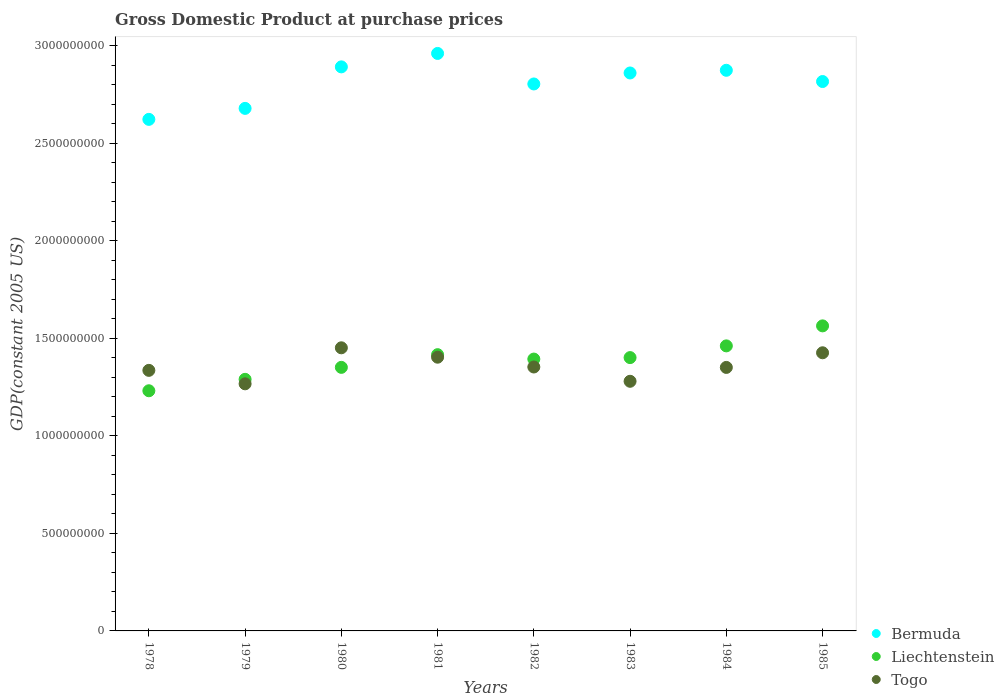How many different coloured dotlines are there?
Give a very brief answer. 3. Is the number of dotlines equal to the number of legend labels?
Offer a terse response. Yes. What is the GDP at purchase prices in Bermuda in 1981?
Provide a succinct answer. 2.96e+09. Across all years, what is the maximum GDP at purchase prices in Bermuda?
Ensure brevity in your answer.  2.96e+09. Across all years, what is the minimum GDP at purchase prices in Liechtenstein?
Give a very brief answer. 1.23e+09. In which year was the GDP at purchase prices in Togo maximum?
Your answer should be compact. 1980. In which year was the GDP at purchase prices in Togo minimum?
Make the answer very short. 1979. What is the total GDP at purchase prices in Liechtenstein in the graph?
Make the answer very short. 1.11e+1. What is the difference between the GDP at purchase prices in Liechtenstein in 1983 and that in 1984?
Provide a succinct answer. -6.01e+07. What is the difference between the GDP at purchase prices in Liechtenstein in 1984 and the GDP at purchase prices in Bermuda in 1982?
Your answer should be very brief. -1.34e+09. What is the average GDP at purchase prices in Bermuda per year?
Offer a terse response. 2.81e+09. In the year 1983, what is the difference between the GDP at purchase prices in Togo and GDP at purchase prices in Bermuda?
Your answer should be compact. -1.58e+09. In how many years, is the GDP at purchase prices in Togo greater than 800000000 US$?
Your answer should be compact. 8. What is the ratio of the GDP at purchase prices in Togo in 1981 to that in 1982?
Your response must be concise. 1.04. What is the difference between the highest and the second highest GDP at purchase prices in Togo?
Offer a very short reply. 2.55e+07. What is the difference between the highest and the lowest GDP at purchase prices in Bermuda?
Your answer should be compact. 3.38e+08. Is the sum of the GDP at purchase prices in Togo in 1979 and 1984 greater than the maximum GDP at purchase prices in Liechtenstein across all years?
Provide a short and direct response. Yes. Is it the case that in every year, the sum of the GDP at purchase prices in Togo and GDP at purchase prices in Liechtenstein  is greater than the GDP at purchase prices in Bermuda?
Your answer should be very brief. No. Is the GDP at purchase prices in Togo strictly greater than the GDP at purchase prices in Bermuda over the years?
Offer a terse response. No. Is the GDP at purchase prices in Liechtenstein strictly less than the GDP at purchase prices in Bermuda over the years?
Your answer should be compact. Yes. How many years are there in the graph?
Offer a terse response. 8. Are the values on the major ticks of Y-axis written in scientific E-notation?
Your answer should be compact. No. Does the graph contain grids?
Your answer should be compact. No. How many legend labels are there?
Make the answer very short. 3. What is the title of the graph?
Your response must be concise. Gross Domestic Product at purchase prices. Does "West Bank and Gaza" appear as one of the legend labels in the graph?
Provide a short and direct response. No. What is the label or title of the Y-axis?
Make the answer very short. GDP(constant 2005 US). What is the GDP(constant 2005 US) in Bermuda in 1978?
Make the answer very short. 2.62e+09. What is the GDP(constant 2005 US) of Liechtenstein in 1978?
Keep it short and to the point. 1.23e+09. What is the GDP(constant 2005 US) of Togo in 1978?
Ensure brevity in your answer.  1.34e+09. What is the GDP(constant 2005 US) in Bermuda in 1979?
Keep it short and to the point. 2.68e+09. What is the GDP(constant 2005 US) in Liechtenstein in 1979?
Offer a very short reply. 1.29e+09. What is the GDP(constant 2005 US) in Togo in 1979?
Your answer should be very brief. 1.27e+09. What is the GDP(constant 2005 US) in Bermuda in 1980?
Offer a very short reply. 2.89e+09. What is the GDP(constant 2005 US) of Liechtenstein in 1980?
Your response must be concise. 1.35e+09. What is the GDP(constant 2005 US) of Togo in 1980?
Give a very brief answer. 1.45e+09. What is the GDP(constant 2005 US) in Bermuda in 1981?
Provide a short and direct response. 2.96e+09. What is the GDP(constant 2005 US) in Liechtenstein in 1981?
Make the answer very short. 1.42e+09. What is the GDP(constant 2005 US) of Togo in 1981?
Your response must be concise. 1.40e+09. What is the GDP(constant 2005 US) of Bermuda in 1982?
Offer a terse response. 2.80e+09. What is the GDP(constant 2005 US) of Liechtenstein in 1982?
Give a very brief answer. 1.39e+09. What is the GDP(constant 2005 US) of Togo in 1982?
Your answer should be compact. 1.35e+09. What is the GDP(constant 2005 US) in Bermuda in 1983?
Provide a succinct answer. 2.86e+09. What is the GDP(constant 2005 US) of Liechtenstein in 1983?
Offer a very short reply. 1.40e+09. What is the GDP(constant 2005 US) in Togo in 1983?
Make the answer very short. 1.28e+09. What is the GDP(constant 2005 US) in Bermuda in 1984?
Provide a succinct answer. 2.87e+09. What is the GDP(constant 2005 US) in Liechtenstein in 1984?
Keep it short and to the point. 1.46e+09. What is the GDP(constant 2005 US) in Togo in 1984?
Your answer should be compact. 1.35e+09. What is the GDP(constant 2005 US) in Bermuda in 1985?
Give a very brief answer. 2.82e+09. What is the GDP(constant 2005 US) of Liechtenstein in 1985?
Keep it short and to the point. 1.56e+09. What is the GDP(constant 2005 US) of Togo in 1985?
Your answer should be very brief. 1.43e+09. Across all years, what is the maximum GDP(constant 2005 US) in Bermuda?
Make the answer very short. 2.96e+09. Across all years, what is the maximum GDP(constant 2005 US) in Liechtenstein?
Provide a short and direct response. 1.56e+09. Across all years, what is the maximum GDP(constant 2005 US) of Togo?
Give a very brief answer. 1.45e+09. Across all years, what is the minimum GDP(constant 2005 US) of Bermuda?
Ensure brevity in your answer.  2.62e+09. Across all years, what is the minimum GDP(constant 2005 US) in Liechtenstein?
Give a very brief answer. 1.23e+09. Across all years, what is the minimum GDP(constant 2005 US) in Togo?
Ensure brevity in your answer.  1.27e+09. What is the total GDP(constant 2005 US) in Bermuda in the graph?
Give a very brief answer. 2.25e+1. What is the total GDP(constant 2005 US) in Liechtenstein in the graph?
Keep it short and to the point. 1.11e+1. What is the total GDP(constant 2005 US) of Togo in the graph?
Your answer should be very brief. 1.09e+1. What is the difference between the GDP(constant 2005 US) in Bermuda in 1978 and that in 1979?
Make the answer very short. -5.63e+07. What is the difference between the GDP(constant 2005 US) in Liechtenstein in 1978 and that in 1979?
Offer a very short reply. -5.86e+07. What is the difference between the GDP(constant 2005 US) of Togo in 1978 and that in 1979?
Provide a short and direct response. 6.90e+07. What is the difference between the GDP(constant 2005 US) of Bermuda in 1978 and that in 1980?
Offer a terse response. -2.69e+08. What is the difference between the GDP(constant 2005 US) of Liechtenstein in 1978 and that in 1980?
Offer a very short reply. -1.20e+08. What is the difference between the GDP(constant 2005 US) in Togo in 1978 and that in 1980?
Provide a short and direct response. -1.16e+08. What is the difference between the GDP(constant 2005 US) in Bermuda in 1978 and that in 1981?
Keep it short and to the point. -3.38e+08. What is the difference between the GDP(constant 2005 US) in Liechtenstein in 1978 and that in 1981?
Offer a very short reply. -1.85e+08. What is the difference between the GDP(constant 2005 US) of Togo in 1978 and that in 1981?
Make the answer very short. -6.75e+07. What is the difference between the GDP(constant 2005 US) in Bermuda in 1978 and that in 1982?
Offer a very short reply. -1.82e+08. What is the difference between the GDP(constant 2005 US) of Liechtenstein in 1978 and that in 1982?
Make the answer very short. -1.63e+08. What is the difference between the GDP(constant 2005 US) in Togo in 1978 and that in 1982?
Offer a very short reply. -1.72e+07. What is the difference between the GDP(constant 2005 US) in Bermuda in 1978 and that in 1983?
Offer a very short reply. -2.38e+08. What is the difference between the GDP(constant 2005 US) of Liechtenstein in 1978 and that in 1983?
Make the answer very short. -1.70e+08. What is the difference between the GDP(constant 2005 US) in Togo in 1978 and that in 1983?
Your answer should be very brief. 5.60e+07. What is the difference between the GDP(constant 2005 US) of Bermuda in 1978 and that in 1984?
Offer a very short reply. -2.52e+08. What is the difference between the GDP(constant 2005 US) in Liechtenstein in 1978 and that in 1984?
Your response must be concise. -2.30e+08. What is the difference between the GDP(constant 2005 US) of Togo in 1978 and that in 1984?
Offer a very short reply. -1.51e+07. What is the difference between the GDP(constant 2005 US) of Bermuda in 1978 and that in 1985?
Keep it short and to the point. -1.94e+08. What is the difference between the GDP(constant 2005 US) of Liechtenstein in 1978 and that in 1985?
Your answer should be very brief. -3.33e+08. What is the difference between the GDP(constant 2005 US) of Togo in 1978 and that in 1985?
Offer a very short reply. -9.01e+07. What is the difference between the GDP(constant 2005 US) in Bermuda in 1979 and that in 1980?
Provide a short and direct response. -2.13e+08. What is the difference between the GDP(constant 2005 US) of Liechtenstein in 1979 and that in 1980?
Make the answer very short. -6.14e+07. What is the difference between the GDP(constant 2005 US) of Togo in 1979 and that in 1980?
Make the answer very short. -1.85e+08. What is the difference between the GDP(constant 2005 US) in Bermuda in 1979 and that in 1981?
Provide a succinct answer. -2.82e+08. What is the difference between the GDP(constant 2005 US) of Liechtenstein in 1979 and that in 1981?
Offer a terse response. -1.26e+08. What is the difference between the GDP(constant 2005 US) of Togo in 1979 and that in 1981?
Your answer should be very brief. -1.37e+08. What is the difference between the GDP(constant 2005 US) in Bermuda in 1979 and that in 1982?
Provide a succinct answer. -1.25e+08. What is the difference between the GDP(constant 2005 US) in Liechtenstein in 1979 and that in 1982?
Your response must be concise. -1.04e+08. What is the difference between the GDP(constant 2005 US) in Togo in 1979 and that in 1982?
Offer a very short reply. -8.63e+07. What is the difference between the GDP(constant 2005 US) in Bermuda in 1979 and that in 1983?
Your response must be concise. -1.82e+08. What is the difference between the GDP(constant 2005 US) of Liechtenstein in 1979 and that in 1983?
Your answer should be compact. -1.11e+08. What is the difference between the GDP(constant 2005 US) of Togo in 1979 and that in 1983?
Make the answer very short. -1.30e+07. What is the difference between the GDP(constant 2005 US) in Bermuda in 1979 and that in 1984?
Your answer should be compact. -1.95e+08. What is the difference between the GDP(constant 2005 US) of Liechtenstein in 1979 and that in 1984?
Your answer should be compact. -1.72e+08. What is the difference between the GDP(constant 2005 US) of Togo in 1979 and that in 1984?
Give a very brief answer. -8.41e+07. What is the difference between the GDP(constant 2005 US) of Bermuda in 1979 and that in 1985?
Your answer should be very brief. -1.38e+08. What is the difference between the GDP(constant 2005 US) of Liechtenstein in 1979 and that in 1985?
Your response must be concise. -2.74e+08. What is the difference between the GDP(constant 2005 US) in Togo in 1979 and that in 1985?
Provide a succinct answer. -1.59e+08. What is the difference between the GDP(constant 2005 US) in Bermuda in 1980 and that in 1981?
Offer a very short reply. -6.89e+07. What is the difference between the GDP(constant 2005 US) in Liechtenstein in 1980 and that in 1981?
Your answer should be compact. -6.51e+07. What is the difference between the GDP(constant 2005 US) of Togo in 1980 and that in 1981?
Give a very brief answer. 4.81e+07. What is the difference between the GDP(constant 2005 US) of Bermuda in 1980 and that in 1982?
Ensure brevity in your answer.  8.76e+07. What is the difference between the GDP(constant 2005 US) in Liechtenstein in 1980 and that in 1982?
Offer a terse response. -4.25e+07. What is the difference between the GDP(constant 2005 US) in Togo in 1980 and that in 1982?
Give a very brief answer. 9.84e+07. What is the difference between the GDP(constant 2005 US) of Bermuda in 1980 and that in 1983?
Provide a succinct answer. 3.13e+07. What is the difference between the GDP(constant 2005 US) in Liechtenstein in 1980 and that in 1983?
Offer a terse response. -5.01e+07. What is the difference between the GDP(constant 2005 US) of Togo in 1980 and that in 1983?
Give a very brief answer. 1.72e+08. What is the difference between the GDP(constant 2005 US) of Bermuda in 1980 and that in 1984?
Make the answer very short. 1.75e+07. What is the difference between the GDP(constant 2005 US) of Liechtenstein in 1980 and that in 1984?
Keep it short and to the point. -1.10e+08. What is the difference between the GDP(constant 2005 US) of Togo in 1980 and that in 1984?
Offer a very short reply. 1.01e+08. What is the difference between the GDP(constant 2005 US) in Bermuda in 1980 and that in 1985?
Your response must be concise. 7.51e+07. What is the difference between the GDP(constant 2005 US) in Liechtenstein in 1980 and that in 1985?
Your answer should be compact. -2.13e+08. What is the difference between the GDP(constant 2005 US) in Togo in 1980 and that in 1985?
Your response must be concise. 2.55e+07. What is the difference between the GDP(constant 2005 US) of Bermuda in 1981 and that in 1982?
Make the answer very short. 1.57e+08. What is the difference between the GDP(constant 2005 US) of Liechtenstein in 1981 and that in 1982?
Your answer should be very brief. 2.25e+07. What is the difference between the GDP(constant 2005 US) in Togo in 1981 and that in 1982?
Give a very brief answer. 5.03e+07. What is the difference between the GDP(constant 2005 US) in Bermuda in 1981 and that in 1983?
Your answer should be very brief. 1.00e+08. What is the difference between the GDP(constant 2005 US) in Liechtenstein in 1981 and that in 1983?
Your answer should be very brief. 1.50e+07. What is the difference between the GDP(constant 2005 US) of Togo in 1981 and that in 1983?
Ensure brevity in your answer.  1.24e+08. What is the difference between the GDP(constant 2005 US) of Bermuda in 1981 and that in 1984?
Make the answer very short. 8.64e+07. What is the difference between the GDP(constant 2005 US) in Liechtenstein in 1981 and that in 1984?
Keep it short and to the point. -4.50e+07. What is the difference between the GDP(constant 2005 US) of Togo in 1981 and that in 1984?
Offer a very short reply. 5.24e+07. What is the difference between the GDP(constant 2005 US) in Bermuda in 1981 and that in 1985?
Offer a terse response. 1.44e+08. What is the difference between the GDP(constant 2005 US) of Liechtenstein in 1981 and that in 1985?
Make the answer very short. -1.48e+08. What is the difference between the GDP(constant 2005 US) in Togo in 1981 and that in 1985?
Provide a succinct answer. -2.26e+07. What is the difference between the GDP(constant 2005 US) of Bermuda in 1982 and that in 1983?
Provide a short and direct response. -5.63e+07. What is the difference between the GDP(constant 2005 US) in Liechtenstein in 1982 and that in 1983?
Give a very brief answer. -7.51e+06. What is the difference between the GDP(constant 2005 US) of Togo in 1982 and that in 1983?
Your response must be concise. 7.33e+07. What is the difference between the GDP(constant 2005 US) in Bermuda in 1982 and that in 1984?
Provide a succinct answer. -7.01e+07. What is the difference between the GDP(constant 2005 US) in Liechtenstein in 1982 and that in 1984?
Provide a succinct answer. -6.76e+07. What is the difference between the GDP(constant 2005 US) of Togo in 1982 and that in 1984?
Ensure brevity in your answer.  2.15e+06. What is the difference between the GDP(constant 2005 US) in Bermuda in 1982 and that in 1985?
Your response must be concise. -1.25e+07. What is the difference between the GDP(constant 2005 US) in Liechtenstein in 1982 and that in 1985?
Provide a succinct answer. -1.70e+08. What is the difference between the GDP(constant 2005 US) in Togo in 1982 and that in 1985?
Your answer should be very brief. -7.29e+07. What is the difference between the GDP(constant 2005 US) of Bermuda in 1983 and that in 1984?
Offer a terse response. -1.38e+07. What is the difference between the GDP(constant 2005 US) of Liechtenstein in 1983 and that in 1984?
Offer a terse response. -6.01e+07. What is the difference between the GDP(constant 2005 US) in Togo in 1983 and that in 1984?
Offer a terse response. -7.11e+07. What is the difference between the GDP(constant 2005 US) of Bermuda in 1983 and that in 1985?
Provide a short and direct response. 4.38e+07. What is the difference between the GDP(constant 2005 US) of Liechtenstein in 1983 and that in 1985?
Offer a terse response. -1.63e+08. What is the difference between the GDP(constant 2005 US) in Togo in 1983 and that in 1985?
Offer a very short reply. -1.46e+08. What is the difference between the GDP(constant 2005 US) of Bermuda in 1984 and that in 1985?
Your response must be concise. 5.76e+07. What is the difference between the GDP(constant 2005 US) in Liechtenstein in 1984 and that in 1985?
Provide a short and direct response. -1.03e+08. What is the difference between the GDP(constant 2005 US) of Togo in 1984 and that in 1985?
Offer a very short reply. -7.51e+07. What is the difference between the GDP(constant 2005 US) of Bermuda in 1978 and the GDP(constant 2005 US) of Liechtenstein in 1979?
Keep it short and to the point. 1.33e+09. What is the difference between the GDP(constant 2005 US) of Bermuda in 1978 and the GDP(constant 2005 US) of Togo in 1979?
Provide a succinct answer. 1.36e+09. What is the difference between the GDP(constant 2005 US) in Liechtenstein in 1978 and the GDP(constant 2005 US) in Togo in 1979?
Make the answer very short. -3.56e+07. What is the difference between the GDP(constant 2005 US) of Bermuda in 1978 and the GDP(constant 2005 US) of Liechtenstein in 1980?
Your response must be concise. 1.27e+09. What is the difference between the GDP(constant 2005 US) in Bermuda in 1978 and the GDP(constant 2005 US) in Togo in 1980?
Provide a succinct answer. 1.17e+09. What is the difference between the GDP(constant 2005 US) in Liechtenstein in 1978 and the GDP(constant 2005 US) in Togo in 1980?
Provide a succinct answer. -2.20e+08. What is the difference between the GDP(constant 2005 US) in Bermuda in 1978 and the GDP(constant 2005 US) in Liechtenstein in 1981?
Provide a short and direct response. 1.21e+09. What is the difference between the GDP(constant 2005 US) of Bermuda in 1978 and the GDP(constant 2005 US) of Togo in 1981?
Your answer should be very brief. 1.22e+09. What is the difference between the GDP(constant 2005 US) in Liechtenstein in 1978 and the GDP(constant 2005 US) in Togo in 1981?
Provide a short and direct response. -1.72e+08. What is the difference between the GDP(constant 2005 US) of Bermuda in 1978 and the GDP(constant 2005 US) of Liechtenstein in 1982?
Offer a very short reply. 1.23e+09. What is the difference between the GDP(constant 2005 US) of Bermuda in 1978 and the GDP(constant 2005 US) of Togo in 1982?
Your answer should be compact. 1.27e+09. What is the difference between the GDP(constant 2005 US) of Liechtenstein in 1978 and the GDP(constant 2005 US) of Togo in 1982?
Provide a succinct answer. -1.22e+08. What is the difference between the GDP(constant 2005 US) in Bermuda in 1978 and the GDP(constant 2005 US) in Liechtenstein in 1983?
Provide a short and direct response. 1.22e+09. What is the difference between the GDP(constant 2005 US) in Bermuda in 1978 and the GDP(constant 2005 US) in Togo in 1983?
Offer a very short reply. 1.34e+09. What is the difference between the GDP(constant 2005 US) in Liechtenstein in 1978 and the GDP(constant 2005 US) in Togo in 1983?
Make the answer very short. -4.86e+07. What is the difference between the GDP(constant 2005 US) of Bermuda in 1978 and the GDP(constant 2005 US) of Liechtenstein in 1984?
Provide a succinct answer. 1.16e+09. What is the difference between the GDP(constant 2005 US) in Bermuda in 1978 and the GDP(constant 2005 US) in Togo in 1984?
Offer a very short reply. 1.27e+09. What is the difference between the GDP(constant 2005 US) of Liechtenstein in 1978 and the GDP(constant 2005 US) of Togo in 1984?
Offer a very short reply. -1.20e+08. What is the difference between the GDP(constant 2005 US) of Bermuda in 1978 and the GDP(constant 2005 US) of Liechtenstein in 1985?
Your answer should be very brief. 1.06e+09. What is the difference between the GDP(constant 2005 US) of Bermuda in 1978 and the GDP(constant 2005 US) of Togo in 1985?
Keep it short and to the point. 1.20e+09. What is the difference between the GDP(constant 2005 US) in Liechtenstein in 1978 and the GDP(constant 2005 US) in Togo in 1985?
Offer a terse response. -1.95e+08. What is the difference between the GDP(constant 2005 US) of Bermuda in 1979 and the GDP(constant 2005 US) of Liechtenstein in 1980?
Provide a short and direct response. 1.33e+09. What is the difference between the GDP(constant 2005 US) of Bermuda in 1979 and the GDP(constant 2005 US) of Togo in 1980?
Offer a terse response. 1.23e+09. What is the difference between the GDP(constant 2005 US) of Liechtenstein in 1979 and the GDP(constant 2005 US) of Togo in 1980?
Your response must be concise. -1.62e+08. What is the difference between the GDP(constant 2005 US) in Bermuda in 1979 and the GDP(constant 2005 US) in Liechtenstein in 1981?
Give a very brief answer. 1.26e+09. What is the difference between the GDP(constant 2005 US) in Bermuda in 1979 and the GDP(constant 2005 US) in Togo in 1981?
Provide a short and direct response. 1.28e+09. What is the difference between the GDP(constant 2005 US) of Liechtenstein in 1979 and the GDP(constant 2005 US) of Togo in 1981?
Ensure brevity in your answer.  -1.14e+08. What is the difference between the GDP(constant 2005 US) of Bermuda in 1979 and the GDP(constant 2005 US) of Liechtenstein in 1982?
Provide a short and direct response. 1.29e+09. What is the difference between the GDP(constant 2005 US) in Bermuda in 1979 and the GDP(constant 2005 US) in Togo in 1982?
Make the answer very short. 1.33e+09. What is the difference between the GDP(constant 2005 US) in Liechtenstein in 1979 and the GDP(constant 2005 US) in Togo in 1982?
Make the answer very short. -6.32e+07. What is the difference between the GDP(constant 2005 US) in Bermuda in 1979 and the GDP(constant 2005 US) in Liechtenstein in 1983?
Make the answer very short. 1.28e+09. What is the difference between the GDP(constant 2005 US) in Bermuda in 1979 and the GDP(constant 2005 US) in Togo in 1983?
Offer a very short reply. 1.40e+09. What is the difference between the GDP(constant 2005 US) of Liechtenstein in 1979 and the GDP(constant 2005 US) of Togo in 1983?
Make the answer very short. 1.00e+07. What is the difference between the GDP(constant 2005 US) of Bermuda in 1979 and the GDP(constant 2005 US) of Liechtenstein in 1984?
Offer a very short reply. 1.22e+09. What is the difference between the GDP(constant 2005 US) in Bermuda in 1979 and the GDP(constant 2005 US) in Togo in 1984?
Make the answer very short. 1.33e+09. What is the difference between the GDP(constant 2005 US) in Liechtenstein in 1979 and the GDP(constant 2005 US) in Togo in 1984?
Provide a short and direct response. -6.11e+07. What is the difference between the GDP(constant 2005 US) in Bermuda in 1979 and the GDP(constant 2005 US) in Liechtenstein in 1985?
Your answer should be very brief. 1.12e+09. What is the difference between the GDP(constant 2005 US) of Bermuda in 1979 and the GDP(constant 2005 US) of Togo in 1985?
Provide a short and direct response. 1.25e+09. What is the difference between the GDP(constant 2005 US) of Liechtenstein in 1979 and the GDP(constant 2005 US) of Togo in 1985?
Make the answer very short. -1.36e+08. What is the difference between the GDP(constant 2005 US) in Bermuda in 1980 and the GDP(constant 2005 US) in Liechtenstein in 1981?
Your answer should be compact. 1.48e+09. What is the difference between the GDP(constant 2005 US) of Bermuda in 1980 and the GDP(constant 2005 US) of Togo in 1981?
Offer a terse response. 1.49e+09. What is the difference between the GDP(constant 2005 US) of Liechtenstein in 1980 and the GDP(constant 2005 US) of Togo in 1981?
Your response must be concise. -5.21e+07. What is the difference between the GDP(constant 2005 US) of Bermuda in 1980 and the GDP(constant 2005 US) of Liechtenstein in 1982?
Offer a terse response. 1.50e+09. What is the difference between the GDP(constant 2005 US) in Bermuda in 1980 and the GDP(constant 2005 US) in Togo in 1982?
Give a very brief answer. 1.54e+09. What is the difference between the GDP(constant 2005 US) in Liechtenstein in 1980 and the GDP(constant 2005 US) in Togo in 1982?
Offer a terse response. -1.85e+06. What is the difference between the GDP(constant 2005 US) in Bermuda in 1980 and the GDP(constant 2005 US) in Liechtenstein in 1983?
Ensure brevity in your answer.  1.49e+09. What is the difference between the GDP(constant 2005 US) of Bermuda in 1980 and the GDP(constant 2005 US) of Togo in 1983?
Your answer should be compact. 1.61e+09. What is the difference between the GDP(constant 2005 US) of Liechtenstein in 1980 and the GDP(constant 2005 US) of Togo in 1983?
Give a very brief answer. 7.14e+07. What is the difference between the GDP(constant 2005 US) of Bermuda in 1980 and the GDP(constant 2005 US) of Liechtenstein in 1984?
Give a very brief answer. 1.43e+09. What is the difference between the GDP(constant 2005 US) in Bermuda in 1980 and the GDP(constant 2005 US) in Togo in 1984?
Make the answer very short. 1.54e+09. What is the difference between the GDP(constant 2005 US) in Liechtenstein in 1980 and the GDP(constant 2005 US) in Togo in 1984?
Ensure brevity in your answer.  3.01e+05. What is the difference between the GDP(constant 2005 US) of Bermuda in 1980 and the GDP(constant 2005 US) of Liechtenstein in 1985?
Offer a terse response. 1.33e+09. What is the difference between the GDP(constant 2005 US) of Bermuda in 1980 and the GDP(constant 2005 US) of Togo in 1985?
Make the answer very short. 1.47e+09. What is the difference between the GDP(constant 2005 US) of Liechtenstein in 1980 and the GDP(constant 2005 US) of Togo in 1985?
Make the answer very short. -7.48e+07. What is the difference between the GDP(constant 2005 US) in Bermuda in 1981 and the GDP(constant 2005 US) in Liechtenstein in 1982?
Keep it short and to the point. 1.57e+09. What is the difference between the GDP(constant 2005 US) of Bermuda in 1981 and the GDP(constant 2005 US) of Togo in 1982?
Ensure brevity in your answer.  1.61e+09. What is the difference between the GDP(constant 2005 US) of Liechtenstein in 1981 and the GDP(constant 2005 US) of Togo in 1982?
Your answer should be very brief. 6.32e+07. What is the difference between the GDP(constant 2005 US) of Bermuda in 1981 and the GDP(constant 2005 US) of Liechtenstein in 1983?
Provide a short and direct response. 1.56e+09. What is the difference between the GDP(constant 2005 US) in Bermuda in 1981 and the GDP(constant 2005 US) in Togo in 1983?
Give a very brief answer. 1.68e+09. What is the difference between the GDP(constant 2005 US) of Liechtenstein in 1981 and the GDP(constant 2005 US) of Togo in 1983?
Your answer should be very brief. 1.36e+08. What is the difference between the GDP(constant 2005 US) of Bermuda in 1981 and the GDP(constant 2005 US) of Liechtenstein in 1984?
Provide a short and direct response. 1.50e+09. What is the difference between the GDP(constant 2005 US) of Bermuda in 1981 and the GDP(constant 2005 US) of Togo in 1984?
Your answer should be very brief. 1.61e+09. What is the difference between the GDP(constant 2005 US) in Liechtenstein in 1981 and the GDP(constant 2005 US) in Togo in 1984?
Offer a terse response. 6.54e+07. What is the difference between the GDP(constant 2005 US) in Bermuda in 1981 and the GDP(constant 2005 US) in Liechtenstein in 1985?
Your answer should be compact. 1.40e+09. What is the difference between the GDP(constant 2005 US) in Bermuda in 1981 and the GDP(constant 2005 US) in Togo in 1985?
Your answer should be compact. 1.53e+09. What is the difference between the GDP(constant 2005 US) in Liechtenstein in 1981 and the GDP(constant 2005 US) in Togo in 1985?
Provide a succinct answer. -9.69e+06. What is the difference between the GDP(constant 2005 US) of Bermuda in 1982 and the GDP(constant 2005 US) of Liechtenstein in 1983?
Keep it short and to the point. 1.40e+09. What is the difference between the GDP(constant 2005 US) in Bermuda in 1982 and the GDP(constant 2005 US) in Togo in 1983?
Provide a short and direct response. 1.52e+09. What is the difference between the GDP(constant 2005 US) in Liechtenstein in 1982 and the GDP(constant 2005 US) in Togo in 1983?
Give a very brief answer. 1.14e+08. What is the difference between the GDP(constant 2005 US) of Bermuda in 1982 and the GDP(constant 2005 US) of Liechtenstein in 1984?
Make the answer very short. 1.34e+09. What is the difference between the GDP(constant 2005 US) of Bermuda in 1982 and the GDP(constant 2005 US) of Togo in 1984?
Give a very brief answer. 1.45e+09. What is the difference between the GDP(constant 2005 US) of Liechtenstein in 1982 and the GDP(constant 2005 US) of Togo in 1984?
Offer a terse response. 4.28e+07. What is the difference between the GDP(constant 2005 US) of Bermuda in 1982 and the GDP(constant 2005 US) of Liechtenstein in 1985?
Give a very brief answer. 1.24e+09. What is the difference between the GDP(constant 2005 US) in Bermuda in 1982 and the GDP(constant 2005 US) in Togo in 1985?
Give a very brief answer. 1.38e+09. What is the difference between the GDP(constant 2005 US) in Liechtenstein in 1982 and the GDP(constant 2005 US) in Togo in 1985?
Offer a terse response. -3.22e+07. What is the difference between the GDP(constant 2005 US) in Bermuda in 1983 and the GDP(constant 2005 US) in Liechtenstein in 1984?
Your answer should be compact. 1.40e+09. What is the difference between the GDP(constant 2005 US) in Bermuda in 1983 and the GDP(constant 2005 US) in Togo in 1984?
Provide a short and direct response. 1.51e+09. What is the difference between the GDP(constant 2005 US) of Liechtenstein in 1983 and the GDP(constant 2005 US) of Togo in 1984?
Give a very brief answer. 5.04e+07. What is the difference between the GDP(constant 2005 US) of Bermuda in 1983 and the GDP(constant 2005 US) of Liechtenstein in 1985?
Offer a terse response. 1.30e+09. What is the difference between the GDP(constant 2005 US) of Bermuda in 1983 and the GDP(constant 2005 US) of Togo in 1985?
Offer a very short reply. 1.43e+09. What is the difference between the GDP(constant 2005 US) of Liechtenstein in 1983 and the GDP(constant 2005 US) of Togo in 1985?
Offer a terse response. -2.47e+07. What is the difference between the GDP(constant 2005 US) of Bermuda in 1984 and the GDP(constant 2005 US) of Liechtenstein in 1985?
Offer a terse response. 1.31e+09. What is the difference between the GDP(constant 2005 US) of Bermuda in 1984 and the GDP(constant 2005 US) of Togo in 1985?
Keep it short and to the point. 1.45e+09. What is the difference between the GDP(constant 2005 US) in Liechtenstein in 1984 and the GDP(constant 2005 US) in Togo in 1985?
Provide a succinct answer. 3.54e+07. What is the average GDP(constant 2005 US) in Bermuda per year?
Provide a succinct answer. 2.81e+09. What is the average GDP(constant 2005 US) of Liechtenstein per year?
Your answer should be compact. 1.39e+09. What is the average GDP(constant 2005 US) of Togo per year?
Provide a succinct answer. 1.36e+09. In the year 1978, what is the difference between the GDP(constant 2005 US) in Bermuda and GDP(constant 2005 US) in Liechtenstein?
Offer a terse response. 1.39e+09. In the year 1978, what is the difference between the GDP(constant 2005 US) of Bermuda and GDP(constant 2005 US) of Togo?
Ensure brevity in your answer.  1.29e+09. In the year 1978, what is the difference between the GDP(constant 2005 US) of Liechtenstein and GDP(constant 2005 US) of Togo?
Keep it short and to the point. -1.05e+08. In the year 1979, what is the difference between the GDP(constant 2005 US) in Bermuda and GDP(constant 2005 US) in Liechtenstein?
Keep it short and to the point. 1.39e+09. In the year 1979, what is the difference between the GDP(constant 2005 US) in Bermuda and GDP(constant 2005 US) in Togo?
Your answer should be compact. 1.41e+09. In the year 1979, what is the difference between the GDP(constant 2005 US) in Liechtenstein and GDP(constant 2005 US) in Togo?
Your response must be concise. 2.30e+07. In the year 1980, what is the difference between the GDP(constant 2005 US) of Bermuda and GDP(constant 2005 US) of Liechtenstein?
Your response must be concise. 1.54e+09. In the year 1980, what is the difference between the GDP(constant 2005 US) in Bermuda and GDP(constant 2005 US) in Togo?
Your response must be concise. 1.44e+09. In the year 1980, what is the difference between the GDP(constant 2005 US) of Liechtenstein and GDP(constant 2005 US) of Togo?
Provide a short and direct response. -1.00e+08. In the year 1981, what is the difference between the GDP(constant 2005 US) of Bermuda and GDP(constant 2005 US) of Liechtenstein?
Provide a short and direct response. 1.54e+09. In the year 1981, what is the difference between the GDP(constant 2005 US) in Bermuda and GDP(constant 2005 US) in Togo?
Your answer should be very brief. 1.56e+09. In the year 1981, what is the difference between the GDP(constant 2005 US) in Liechtenstein and GDP(constant 2005 US) in Togo?
Give a very brief answer. 1.29e+07. In the year 1982, what is the difference between the GDP(constant 2005 US) of Bermuda and GDP(constant 2005 US) of Liechtenstein?
Your answer should be very brief. 1.41e+09. In the year 1982, what is the difference between the GDP(constant 2005 US) of Bermuda and GDP(constant 2005 US) of Togo?
Offer a very short reply. 1.45e+09. In the year 1982, what is the difference between the GDP(constant 2005 US) in Liechtenstein and GDP(constant 2005 US) in Togo?
Provide a short and direct response. 4.07e+07. In the year 1983, what is the difference between the GDP(constant 2005 US) in Bermuda and GDP(constant 2005 US) in Liechtenstein?
Provide a short and direct response. 1.46e+09. In the year 1983, what is the difference between the GDP(constant 2005 US) of Bermuda and GDP(constant 2005 US) of Togo?
Offer a very short reply. 1.58e+09. In the year 1983, what is the difference between the GDP(constant 2005 US) of Liechtenstein and GDP(constant 2005 US) of Togo?
Your answer should be very brief. 1.21e+08. In the year 1984, what is the difference between the GDP(constant 2005 US) in Bermuda and GDP(constant 2005 US) in Liechtenstein?
Your response must be concise. 1.41e+09. In the year 1984, what is the difference between the GDP(constant 2005 US) of Bermuda and GDP(constant 2005 US) of Togo?
Your response must be concise. 1.52e+09. In the year 1984, what is the difference between the GDP(constant 2005 US) of Liechtenstein and GDP(constant 2005 US) of Togo?
Give a very brief answer. 1.10e+08. In the year 1985, what is the difference between the GDP(constant 2005 US) in Bermuda and GDP(constant 2005 US) in Liechtenstein?
Keep it short and to the point. 1.25e+09. In the year 1985, what is the difference between the GDP(constant 2005 US) of Bermuda and GDP(constant 2005 US) of Togo?
Provide a succinct answer. 1.39e+09. In the year 1985, what is the difference between the GDP(constant 2005 US) in Liechtenstein and GDP(constant 2005 US) in Togo?
Your response must be concise. 1.38e+08. What is the ratio of the GDP(constant 2005 US) of Liechtenstein in 1978 to that in 1979?
Your response must be concise. 0.95. What is the ratio of the GDP(constant 2005 US) in Togo in 1978 to that in 1979?
Offer a terse response. 1.05. What is the ratio of the GDP(constant 2005 US) of Bermuda in 1978 to that in 1980?
Make the answer very short. 0.91. What is the ratio of the GDP(constant 2005 US) of Liechtenstein in 1978 to that in 1980?
Keep it short and to the point. 0.91. What is the ratio of the GDP(constant 2005 US) in Togo in 1978 to that in 1980?
Give a very brief answer. 0.92. What is the ratio of the GDP(constant 2005 US) of Bermuda in 1978 to that in 1981?
Make the answer very short. 0.89. What is the ratio of the GDP(constant 2005 US) in Liechtenstein in 1978 to that in 1981?
Offer a terse response. 0.87. What is the ratio of the GDP(constant 2005 US) in Togo in 1978 to that in 1981?
Make the answer very short. 0.95. What is the ratio of the GDP(constant 2005 US) of Bermuda in 1978 to that in 1982?
Offer a very short reply. 0.94. What is the ratio of the GDP(constant 2005 US) in Liechtenstein in 1978 to that in 1982?
Offer a very short reply. 0.88. What is the ratio of the GDP(constant 2005 US) in Togo in 1978 to that in 1982?
Give a very brief answer. 0.99. What is the ratio of the GDP(constant 2005 US) of Bermuda in 1978 to that in 1983?
Your answer should be compact. 0.92. What is the ratio of the GDP(constant 2005 US) in Liechtenstein in 1978 to that in 1983?
Offer a very short reply. 0.88. What is the ratio of the GDP(constant 2005 US) of Togo in 1978 to that in 1983?
Offer a very short reply. 1.04. What is the ratio of the GDP(constant 2005 US) of Bermuda in 1978 to that in 1984?
Provide a short and direct response. 0.91. What is the ratio of the GDP(constant 2005 US) in Liechtenstein in 1978 to that in 1984?
Offer a very short reply. 0.84. What is the ratio of the GDP(constant 2005 US) in Togo in 1978 to that in 1984?
Your response must be concise. 0.99. What is the ratio of the GDP(constant 2005 US) in Bermuda in 1978 to that in 1985?
Provide a succinct answer. 0.93. What is the ratio of the GDP(constant 2005 US) of Liechtenstein in 1978 to that in 1985?
Provide a short and direct response. 0.79. What is the ratio of the GDP(constant 2005 US) in Togo in 1978 to that in 1985?
Provide a short and direct response. 0.94. What is the ratio of the GDP(constant 2005 US) in Bermuda in 1979 to that in 1980?
Your answer should be compact. 0.93. What is the ratio of the GDP(constant 2005 US) in Liechtenstein in 1979 to that in 1980?
Your answer should be very brief. 0.95. What is the ratio of the GDP(constant 2005 US) of Togo in 1979 to that in 1980?
Offer a terse response. 0.87. What is the ratio of the GDP(constant 2005 US) of Bermuda in 1979 to that in 1981?
Your answer should be very brief. 0.9. What is the ratio of the GDP(constant 2005 US) in Liechtenstein in 1979 to that in 1981?
Your answer should be very brief. 0.91. What is the ratio of the GDP(constant 2005 US) of Togo in 1979 to that in 1981?
Your response must be concise. 0.9. What is the ratio of the GDP(constant 2005 US) of Bermuda in 1979 to that in 1982?
Your answer should be very brief. 0.96. What is the ratio of the GDP(constant 2005 US) of Liechtenstein in 1979 to that in 1982?
Ensure brevity in your answer.  0.93. What is the ratio of the GDP(constant 2005 US) of Togo in 1979 to that in 1982?
Give a very brief answer. 0.94. What is the ratio of the GDP(constant 2005 US) in Bermuda in 1979 to that in 1983?
Ensure brevity in your answer.  0.94. What is the ratio of the GDP(constant 2005 US) in Liechtenstein in 1979 to that in 1983?
Ensure brevity in your answer.  0.92. What is the ratio of the GDP(constant 2005 US) of Bermuda in 1979 to that in 1984?
Your response must be concise. 0.93. What is the ratio of the GDP(constant 2005 US) in Liechtenstein in 1979 to that in 1984?
Offer a very short reply. 0.88. What is the ratio of the GDP(constant 2005 US) of Togo in 1979 to that in 1984?
Provide a short and direct response. 0.94. What is the ratio of the GDP(constant 2005 US) of Bermuda in 1979 to that in 1985?
Make the answer very short. 0.95. What is the ratio of the GDP(constant 2005 US) in Liechtenstein in 1979 to that in 1985?
Make the answer very short. 0.82. What is the ratio of the GDP(constant 2005 US) of Togo in 1979 to that in 1985?
Make the answer very short. 0.89. What is the ratio of the GDP(constant 2005 US) of Bermuda in 1980 to that in 1981?
Offer a terse response. 0.98. What is the ratio of the GDP(constant 2005 US) in Liechtenstein in 1980 to that in 1981?
Provide a short and direct response. 0.95. What is the ratio of the GDP(constant 2005 US) of Togo in 1980 to that in 1981?
Your answer should be compact. 1.03. What is the ratio of the GDP(constant 2005 US) in Bermuda in 1980 to that in 1982?
Offer a terse response. 1.03. What is the ratio of the GDP(constant 2005 US) of Liechtenstein in 1980 to that in 1982?
Your answer should be compact. 0.97. What is the ratio of the GDP(constant 2005 US) in Togo in 1980 to that in 1982?
Provide a short and direct response. 1.07. What is the ratio of the GDP(constant 2005 US) of Bermuda in 1980 to that in 1983?
Provide a succinct answer. 1.01. What is the ratio of the GDP(constant 2005 US) in Liechtenstein in 1980 to that in 1983?
Give a very brief answer. 0.96. What is the ratio of the GDP(constant 2005 US) of Togo in 1980 to that in 1983?
Provide a succinct answer. 1.13. What is the ratio of the GDP(constant 2005 US) in Liechtenstein in 1980 to that in 1984?
Give a very brief answer. 0.92. What is the ratio of the GDP(constant 2005 US) of Togo in 1980 to that in 1984?
Ensure brevity in your answer.  1.07. What is the ratio of the GDP(constant 2005 US) of Bermuda in 1980 to that in 1985?
Offer a very short reply. 1.03. What is the ratio of the GDP(constant 2005 US) of Liechtenstein in 1980 to that in 1985?
Give a very brief answer. 0.86. What is the ratio of the GDP(constant 2005 US) of Togo in 1980 to that in 1985?
Give a very brief answer. 1.02. What is the ratio of the GDP(constant 2005 US) of Bermuda in 1981 to that in 1982?
Offer a terse response. 1.06. What is the ratio of the GDP(constant 2005 US) in Liechtenstein in 1981 to that in 1982?
Ensure brevity in your answer.  1.02. What is the ratio of the GDP(constant 2005 US) of Togo in 1981 to that in 1982?
Keep it short and to the point. 1.04. What is the ratio of the GDP(constant 2005 US) of Bermuda in 1981 to that in 1983?
Your response must be concise. 1.03. What is the ratio of the GDP(constant 2005 US) in Liechtenstein in 1981 to that in 1983?
Provide a short and direct response. 1.01. What is the ratio of the GDP(constant 2005 US) of Togo in 1981 to that in 1983?
Your answer should be compact. 1.1. What is the ratio of the GDP(constant 2005 US) in Bermuda in 1981 to that in 1984?
Offer a terse response. 1.03. What is the ratio of the GDP(constant 2005 US) in Liechtenstein in 1981 to that in 1984?
Provide a succinct answer. 0.97. What is the ratio of the GDP(constant 2005 US) of Togo in 1981 to that in 1984?
Provide a succinct answer. 1.04. What is the ratio of the GDP(constant 2005 US) of Bermuda in 1981 to that in 1985?
Offer a very short reply. 1.05. What is the ratio of the GDP(constant 2005 US) in Liechtenstein in 1981 to that in 1985?
Give a very brief answer. 0.91. What is the ratio of the GDP(constant 2005 US) in Togo in 1981 to that in 1985?
Ensure brevity in your answer.  0.98. What is the ratio of the GDP(constant 2005 US) in Bermuda in 1982 to that in 1983?
Provide a succinct answer. 0.98. What is the ratio of the GDP(constant 2005 US) of Togo in 1982 to that in 1983?
Ensure brevity in your answer.  1.06. What is the ratio of the GDP(constant 2005 US) of Bermuda in 1982 to that in 1984?
Keep it short and to the point. 0.98. What is the ratio of the GDP(constant 2005 US) in Liechtenstein in 1982 to that in 1984?
Your answer should be compact. 0.95. What is the ratio of the GDP(constant 2005 US) of Togo in 1982 to that in 1984?
Offer a very short reply. 1. What is the ratio of the GDP(constant 2005 US) in Liechtenstein in 1982 to that in 1985?
Your answer should be very brief. 0.89. What is the ratio of the GDP(constant 2005 US) of Togo in 1982 to that in 1985?
Your answer should be compact. 0.95. What is the ratio of the GDP(constant 2005 US) of Bermuda in 1983 to that in 1984?
Give a very brief answer. 1. What is the ratio of the GDP(constant 2005 US) of Liechtenstein in 1983 to that in 1984?
Provide a short and direct response. 0.96. What is the ratio of the GDP(constant 2005 US) in Togo in 1983 to that in 1984?
Make the answer very short. 0.95. What is the ratio of the GDP(constant 2005 US) of Bermuda in 1983 to that in 1985?
Provide a succinct answer. 1.02. What is the ratio of the GDP(constant 2005 US) of Liechtenstein in 1983 to that in 1985?
Keep it short and to the point. 0.9. What is the ratio of the GDP(constant 2005 US) in Togo in 1983 to that in 1985?
Offer a terse response. 0.9. What is the ratio of the GDP(constant 2005 US) in Bermuda in 1984 to that in 1985?
Make the answer very short. 1.02. What is the ratio of the GDP(constant 2005 US) of Liechtenstein in 1984 to that in 1985?
Your answer should be very brief. 0.93. What is the ratio of the GDP(constant 2005 US) of Togo in 1984 to that in 1985?
Provide a succinct answer. 0.95. What is the difference between the highest and the second highest GDP(constant 2005 US) in Bermuda?
Give a very brief answer. 6.89e+07. What is the difference between the highest and the second highest GDP(constant 2005 US) of Liechtenstein?
Provide a succinct answer. 1.03e+08. What is the difference between the highest and the second highest GDP(constant 2005 US) of Togo?
Your answer should be very brief. 2.55e+07. What is the difference between the highest and the lowest GDP(constant 2005 US) in Bermuda?
Offer a terse response. 3.38e+08. What is the difference between the highest and the lowest GDP(constant 2005 US) of Liechtenstein?
Ensure brevity in your answer.  3.33e+08. What is the difference between the highest and the lowest GDP(constant 2005 US) of Togo?
Give a very brief answer. 1.85e+08. 